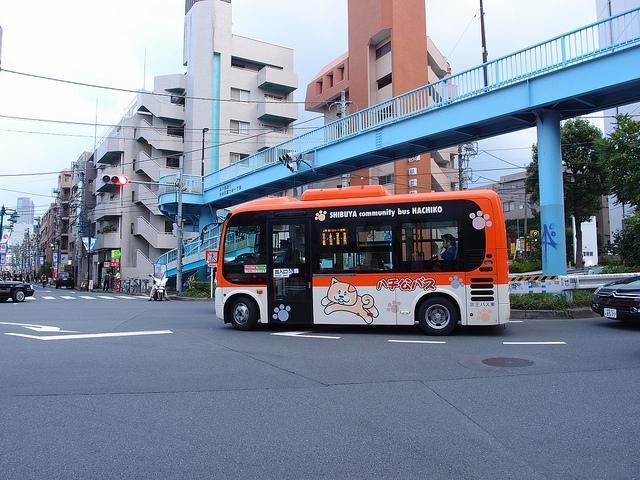How many chairs are on the left side of the table?
Give a very brief answer. 0. 